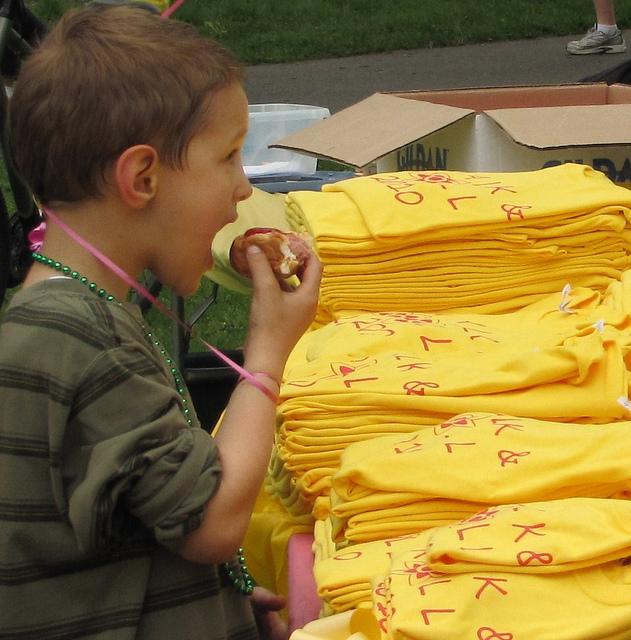What color is the shirt?
Answer briefly. Yellow. What is the boy doing?
Write a very short answer. Eating. Are all of the stacked shirts the same color?
Quick response, please. Yes. What is the boy eating?
Be succinct. Hot dog. 